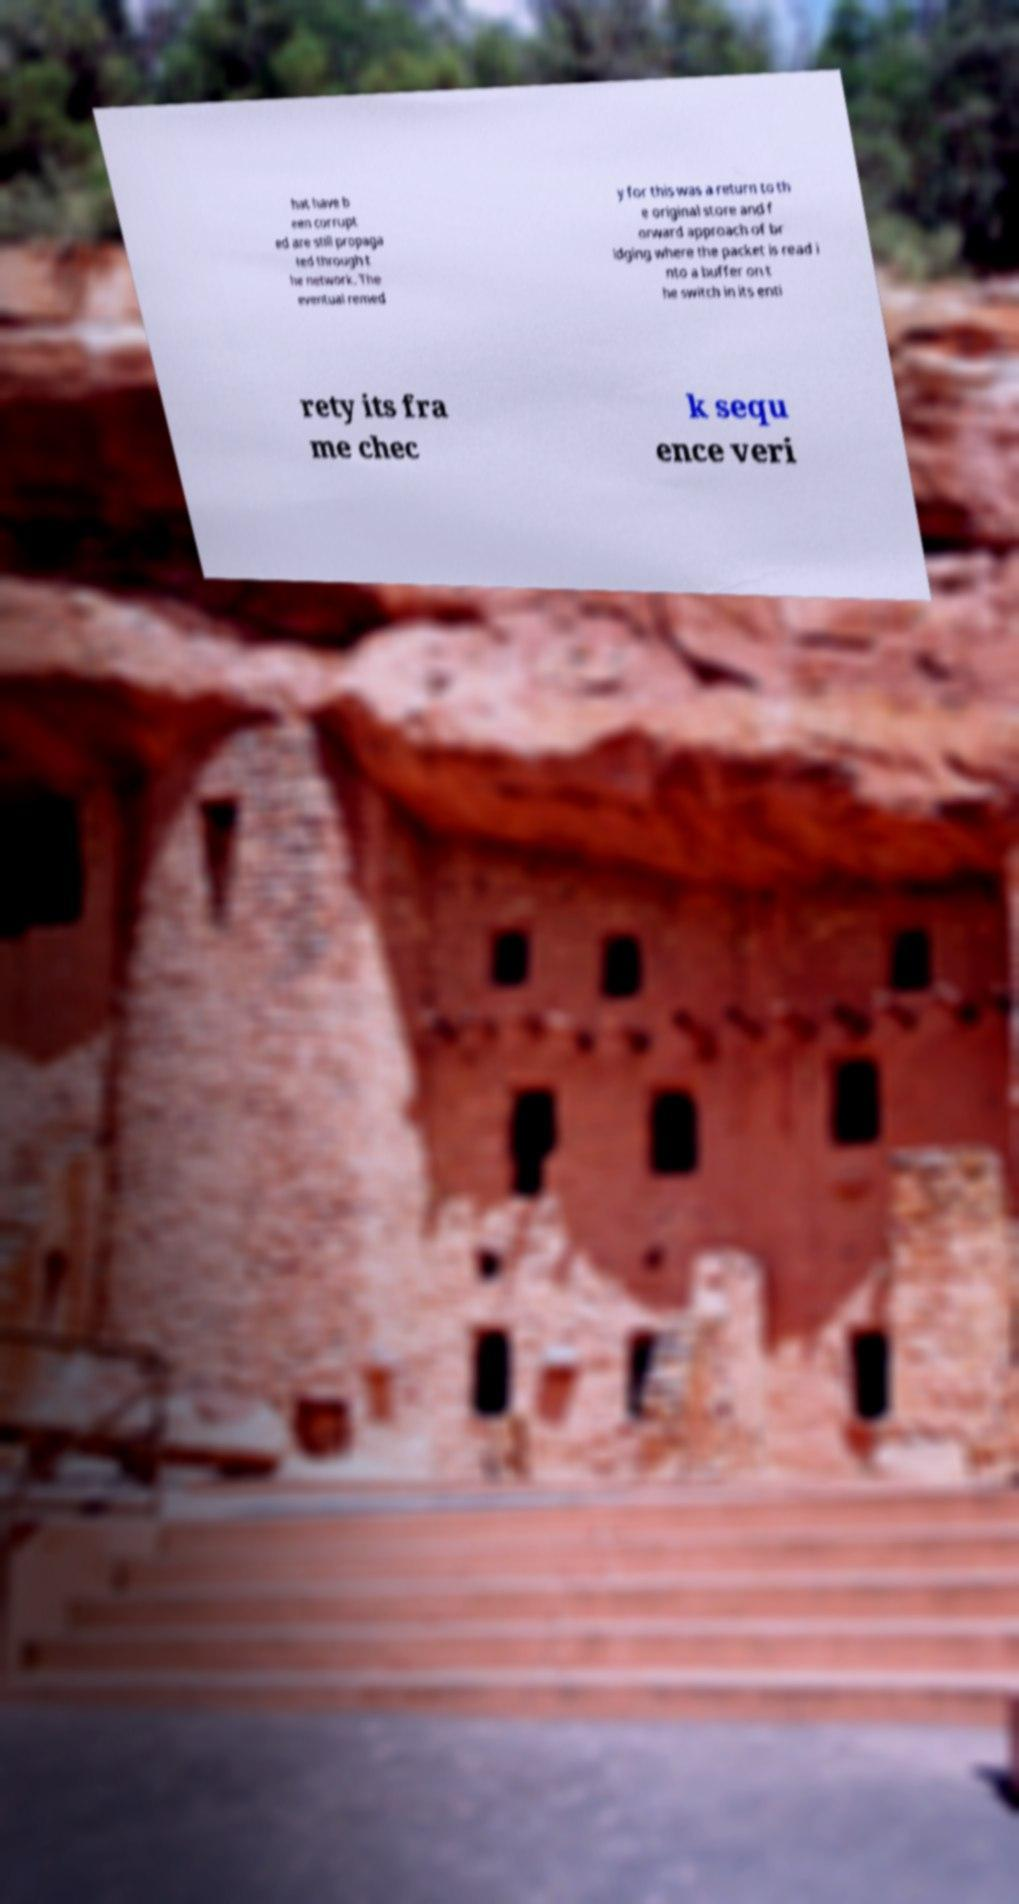Can you read and provide the text displayed in the image?This photo seems to have some interesting text. Can you extract and type it out for me? hat have b een corrupt ed are still propaga ted through t he network. The eventual remed y for this was a return to th e original store and f orward approach of br idging where the packet is read i nto a buffer on t he switch in its enti rety its fra me chec k sequ ence veri 